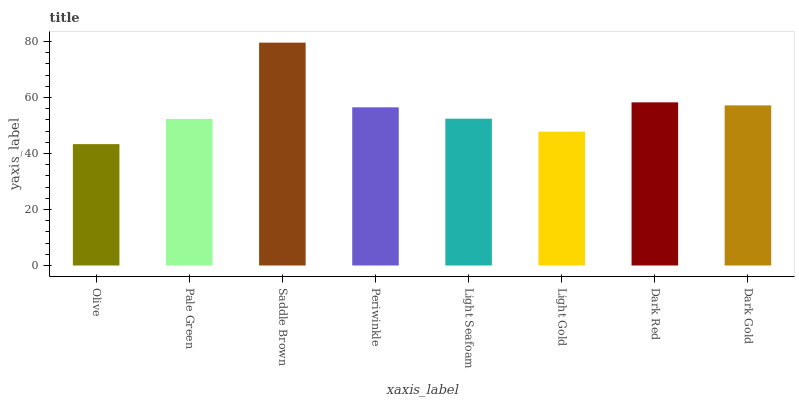Is Olive the minimum?
Answer yes or no. Yes. Is Saddle Brown the maximum?
Answer yes or no. Yes. Is Pale Green the minimum?
Answer yes or no. No. Is Pale Green the maximum?
Answer yes or no. No. Is Pale Green greater than Olive?
Answer yes or no. Yes. Is Olive less than Pale Green?
Answer yes or no. Yes. Is Olive greater than Pale Green?
Answer yes or no. No. Is Pale Green less than Olive?
Answer yes or no. No. Is Periwinkle the high median?
Answer yes or no. Yes. Is Light Seafoam the low median?
Answer yes or no. Yes. Is Dark Gold the high median?
Answer yes or no. No. Is Dark Gold the low median?
Answer yes or no. No. 